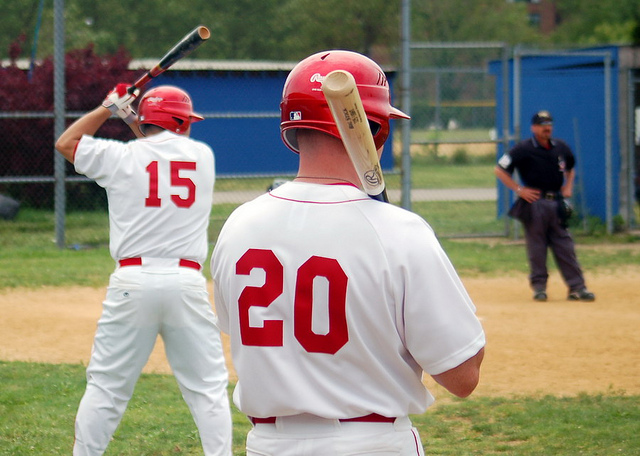Identify the text displayed in this image. 15 20 